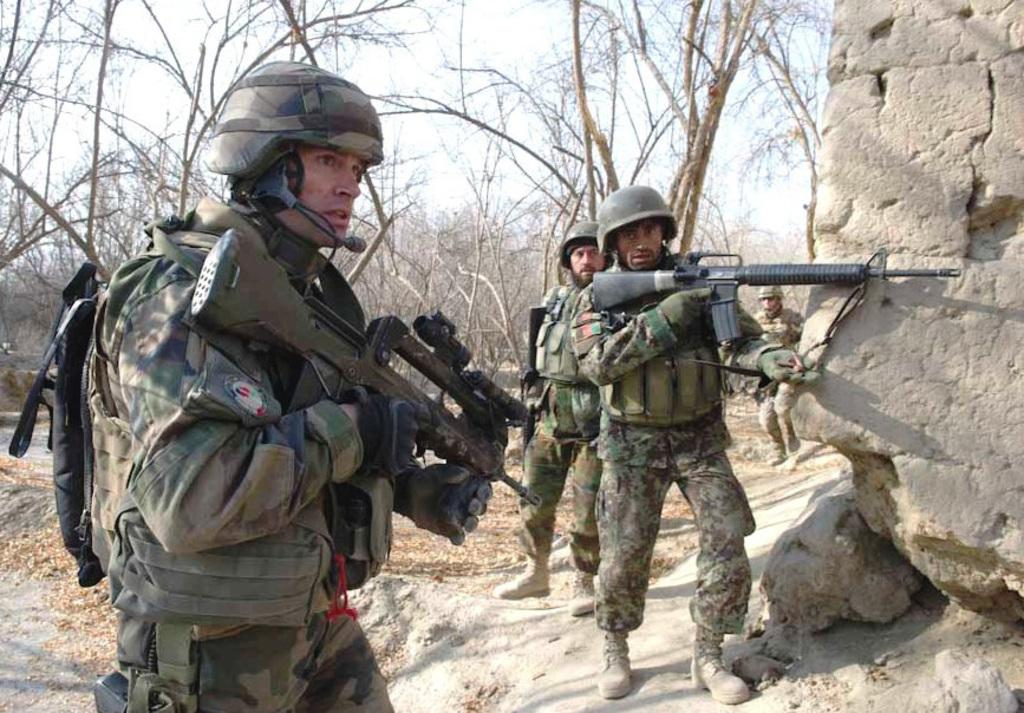What are the men in the image doing? The men in the image are standing on the ground. What are some of the men holding in their hands? Some of the men are holding guns in their hands. What can be seen in the background of the image? In the background of the image, there are shredded leaves, trees, rocks, and the sky. Are the men in the image exchanging gifts with their brothers? There is no indication in the image that the men are exchanging gifts or that they are brothers. 